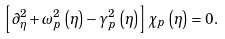<formula> <loc_0><loc_0><loc_500><loc_500>\left [ \partial _ { \eta } ^ { 2 } + \omega _ { p } ^ { 2 } \left ( \eta \right ) - \gamma _ { p } ^ { 2 } \left ( \eta \right ) \right ] \chi _ { p } \left ( \eta \right ) = 0 .</formula> 